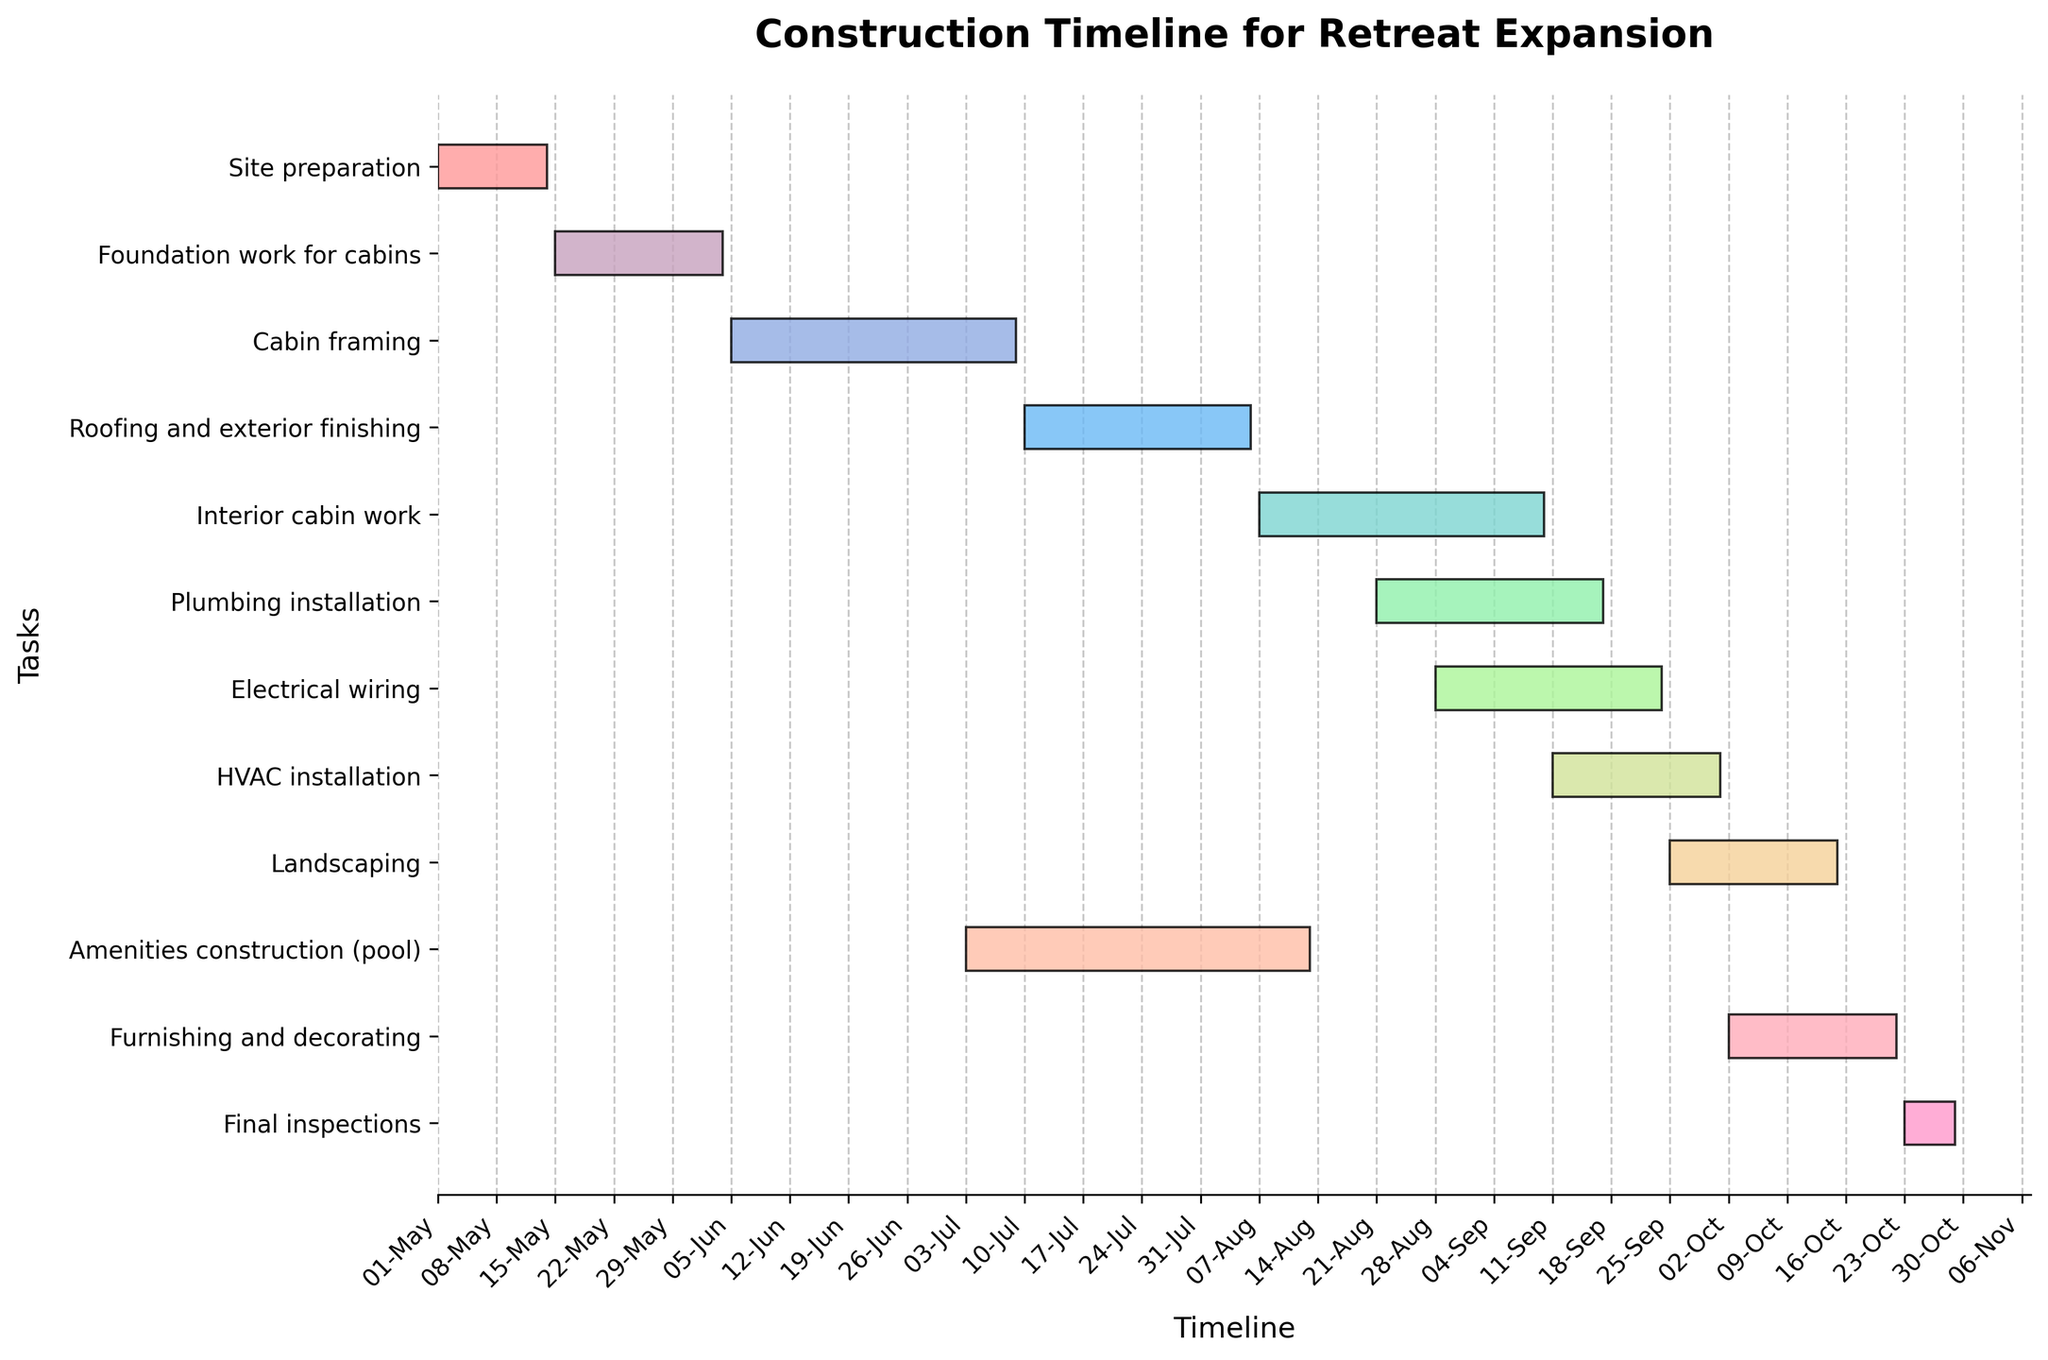What is the title of the Gantt chart? The title of the Gantt chart is usually found at the top of the figure and it summarises what the figure is about. In this case, the title is "Construction Timeline for Retreat Expansion".
Answer: Construction Timeline for Retreat Expansion Which task has the shortest duration? To find the shortest task, look for the bar that represents the task with the smallest length on the horizontal axis. The task "Final inspections" has the shortest duration, spanning 7 days.
Answer: Final inspections How long will the foundation work for the cabins take? To determine the duration of the foundation work for the cabins, locate the "Foundation work for cabins" bar and check the start and end dates or directly refer to the duration provided. The duration is listed as 21 days.
Answer: 21 days Which tasks overlap with the "Interior cabin work"? To find overlapping tasks, identify the duration of "Interior cabin work" (2023-08-07 to 2023-09-10) and see which other tasks have overlapping dates. "Plumbing installation", "Electrical wiring", and "HVAC installation" overlap with "Interior cabin work".
Answer: Plumbing installation, Electrical wiring, HVAC installation What is the total duration of all tasks combined? To find the total duration, sum up the individual durations of all tasks: 14 + 21 + 35 + 28 + 35 + 28 + 28 + 21 + 21 + 42 + 21 + 7 = 301 days.
Answer: 301 days When does the construction of the amenities (pool) start? To ascertain the start date of amenities construction, find the bar labeled "Amenities construction (pool)" and note the start date. The start date is 2023-07-03.
Answer: 2023-07-03 Which task starts immediately after "Roofing and exterior finishing"? To determine this, note the end date of "Roofing and exterior finishing" (2023-08-06) and find the next task's start date. The "Interior cabin work" starts immediately after on 2023-08-07.
Answer: Interior cabin work How many tasks are there in total? Count the number of bars (tasks) present in the Gantt chart. There are 12 tasks listed.
Answer: 12 Which tasks are scheduled to begin in August 2023? To find the tasks starting in August 2023, check the start date of each task. "Interior cabin work" (2023-08-07), "Plumbing installation" (2023-08-21), and "Electrical wiring" (2023-08-28) all commence in August 2023.
Answer: Interior cabin work, Plumbing installation, Electrical wiring What is the longest task and its duration? To find the longest task, look for the bar that spans the greatest length. The task "Amenities construction (pool)" lasts the longest with a duration of 42 days.
Answer: Amenities construction (pool), 42 days 